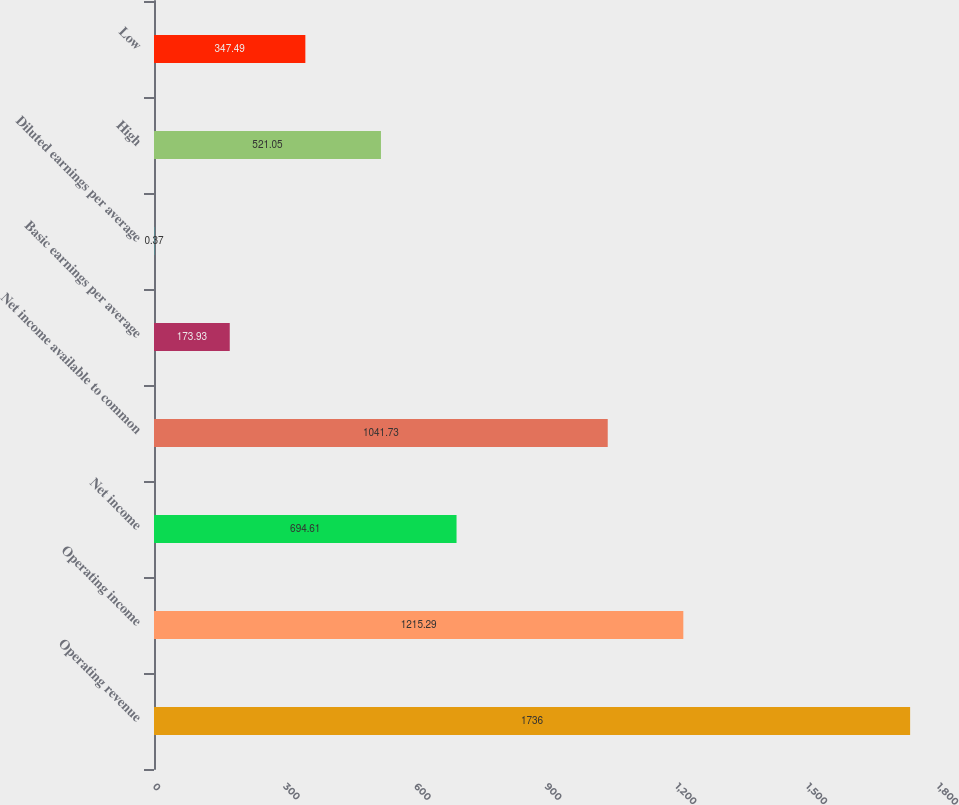Convert chart to OTSL. <chart><loc_0><loc_0><loc_500><loc_500><bar_chart><fcel>Operating revenue<fcel>Operating income<fcel>Net income<fcel>Net income available to common<fcel>Basic earnings per average<fcel>Diluted earnings per average<fcel>High<fcel>Low<nl><fcel>1736<fcel>1215.29<fcel>694.61<fcel>1041.73<fcel>173.93<fcel>0.37<fcel>521.05<fcel>347.49<nl></chart> 